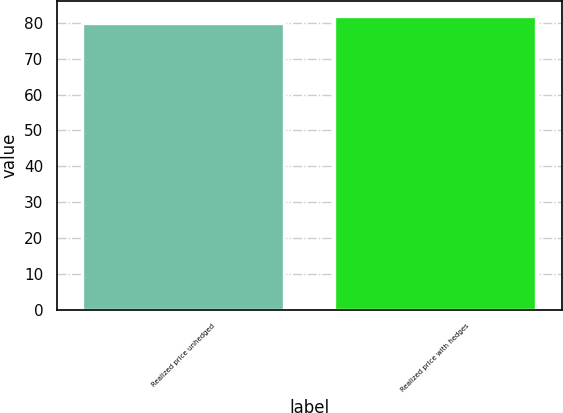Convert chart to OTSL. <chart><loc_0><loc_0><loc_500><loc_500><bar_chart><fcel>Realized price unhedged<fcel>Realized price with hedges<nl><fcel>80<fcel>82<nl></chart> 